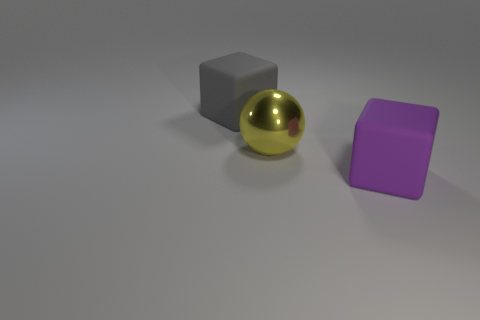Add 3 yellow metallic spheres. How many objects exist? 6 Subtract all blocks. How many objects are left? 1 Subtract 0 green cubes. How many objects are left? 3 Subtract all purple things. Subtract all big yellow things. How many objects are left? 1 Add 2 large yellow metallic balls. How many large yellow metallic balls are left? 3 Add 1 tiny cyan rubber balls. How many tiny cyan rubber balls exist? 1 